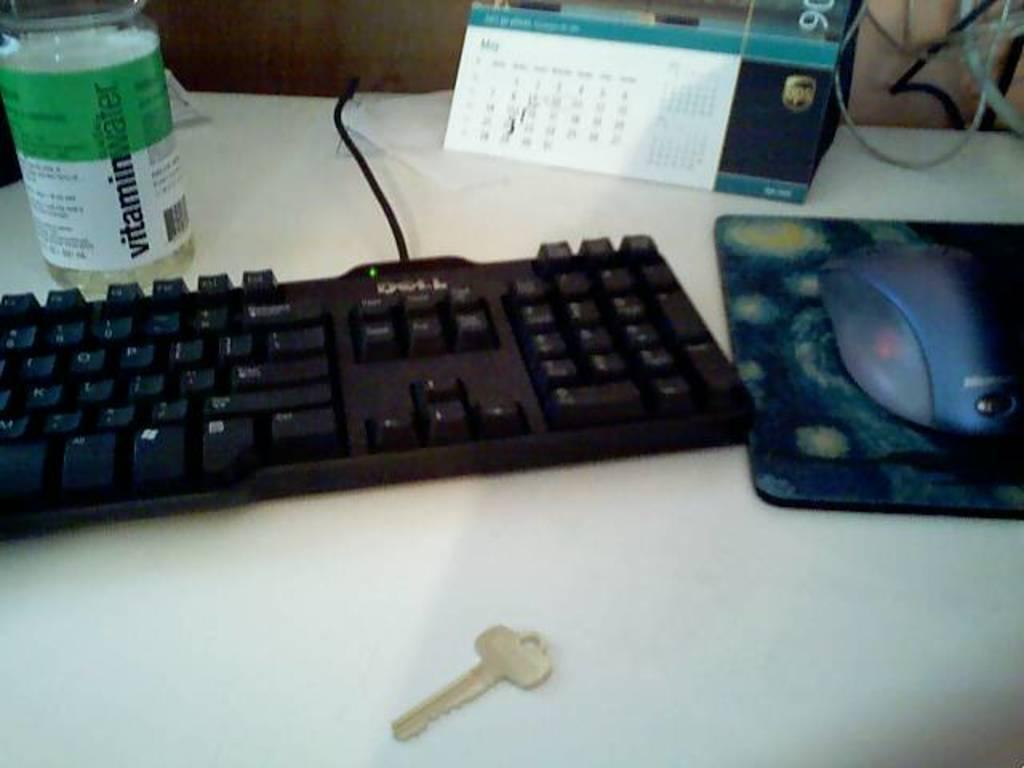<image>
Summarize the visual content of the image. A black Dell keyboard with a half empty Vitamin water sitting next to it. 